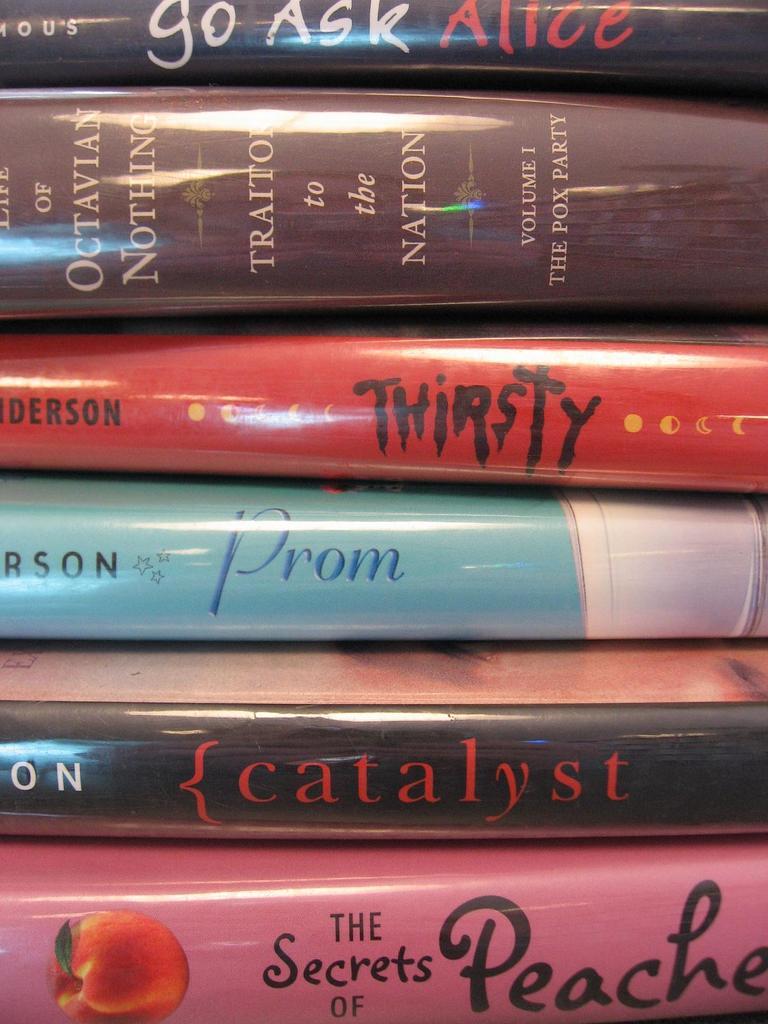What's the name of the red book?
Ensure brevity in your answer.  Thirsty. What title is visible on the book with the peach on it?
Your response must be concise. The secrets of peaches. 